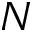<formula> <loc_0><loc_0><loc_500><loc_500>N</formula> 